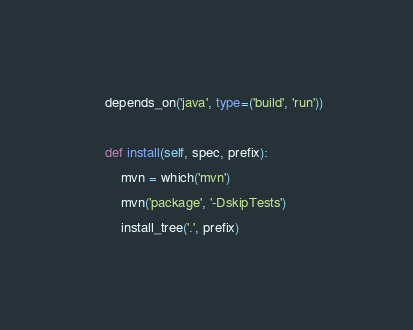Convert code to text. <code><loc_0><loc_0><loc_500><loc_500><_Python_>    depends_on('java', type=('build', 'run'))

    def install(self, spec, prefix):
        mvn = which('mvn')
        mvn('package', '-DskipTests')
        install_tree('.', prefix)
</code> 